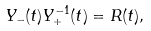<formula> <loc_0><loc_0><loc_500><loc_500>Y _ { - } ( t ) Y _ { + } ^ { - 1 } ( t ) = R ( t ) ,</formula> 